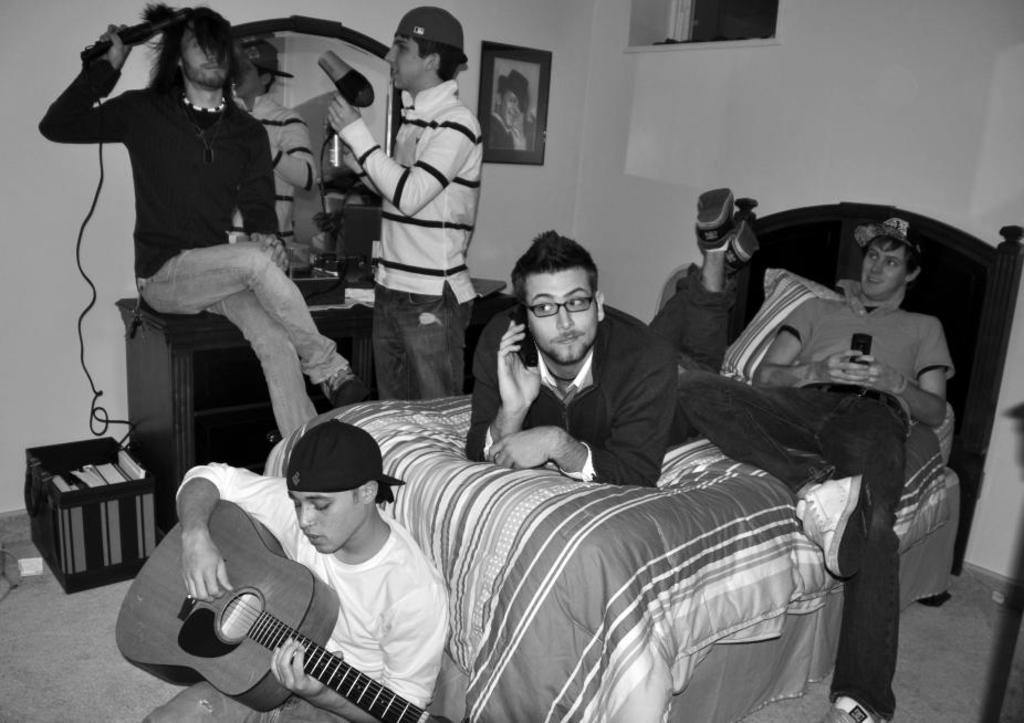How would you summarize this image in a sentence or two? In this picture we can see a group of five friends in the bed room in which one is lying on the bead and talking on the phone other on playing on the phone and in the down one friend is playing a guitar. Opposite to him a boy is sitting on the dressing table and straining his hair and other beside him wearing white t-shirt and pant doing a hair blow to him. Behind him there is a wall on which Michael jackson photo frame is placed with one window on the other wall. 